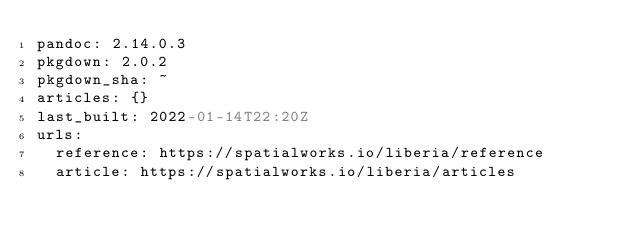<code> <loc_0><loc_0><loc_500><loc_500><_YAML_>pandoc: 2.14.0.3
pkgdown: 2.0.2
pkgdown_sha: ~
articles: {}
last_built: 2022-01-14T22:20Z
urls:
  reference: https://spatialworks.io/liberia/reference
  article: https://spatialworks.io/liberia/articles

</code> 